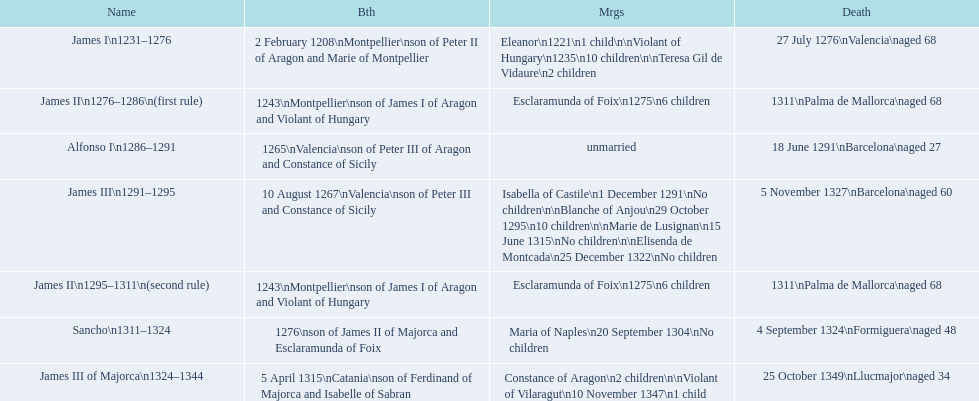James i and james ii both died at what age? 68. I'm looking to parse the entire table for insights. Could you assist me with that? {'header': ['Name', 'Bth', 'Mrgs', 'Death'], 'rows': [['James I\\n1231–1276', '2 February 1208\\nMontpellier\\nson of Peter II of Aragon and Marie of Montpellier', 'Eleanor\\n1221\\n1 child\\n\\nViolant of Hungary\\n1235\\n10 children\\n\\nTeresa Gil de Vidaure\\n2 children', '27 July 1276\\nValencia\\naged 68'], ['James II\\n1276–1286\\n(first rule)', '1243\\nMontpellier\\nson of James I of Aragon and Violant of Hungary', 'Esclaramunda of Foix\\n1275\\n6 children', '1311\\nPalma de Mallorca\\naged 68'], ['Alfonso I\\n1286–1291', '1265\\nValencia\\nson of Peter III of Aragon and Constance of Sicily', 'unmarried', '18 June 1291\\nBarcelona\\naged 27'], ['James III\\n1291–1295', '10 August 1267\\nValencia\\nson of Peter III and Constance of Sicily', 'Isabella of Castile\\n1 December 1291\\nNo children\\n\\nBlanche of Anjou\\n29 October 1295\\n10 children\\n\\nMarie de Lusignan\\n15 June 1315\\nNo children\\n\\nElisenda de Montcada\\n25 December 1322\\nNo children', '5 November 1327\\nBarcelona\\naged 60'], ['James II\\n1295–1311\\n(second rule)', '1243\\nMontpellier\\nson of James I of Aragon and Violant of Hungary', 'Esclaramunda of Foix\\n1275\\n6 children', '1311\\nPalma de Mallorca\\naged 68'], ['Sancho\\n1311–1324', '1276\\nson of James II of Majorca and Esclaramunda of Foix', 'Maria of Naples\\n20 September 1304\\nNo children', '4 September 1324\\nFormiguera\\naged 48'], ['James III of Majorca\\n1324–1344', '5 April 1315\\nCatania\\nson of Ferdinand of Majorca and Isabelle of Sabran', 'Constance of Aragon\\n2 children\\n\\nViolant of Vilaragut\\n10 November 1347\\n1 child', '25 October 1349\\nLlucmajor\\naged 34']]} 